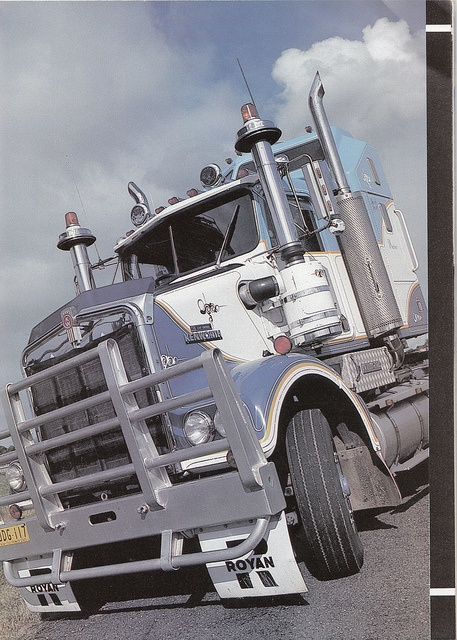Describe the objects in this image and their specific colors. I can see a truck in lightgray, darkgray, gray, and black tones in this image. 